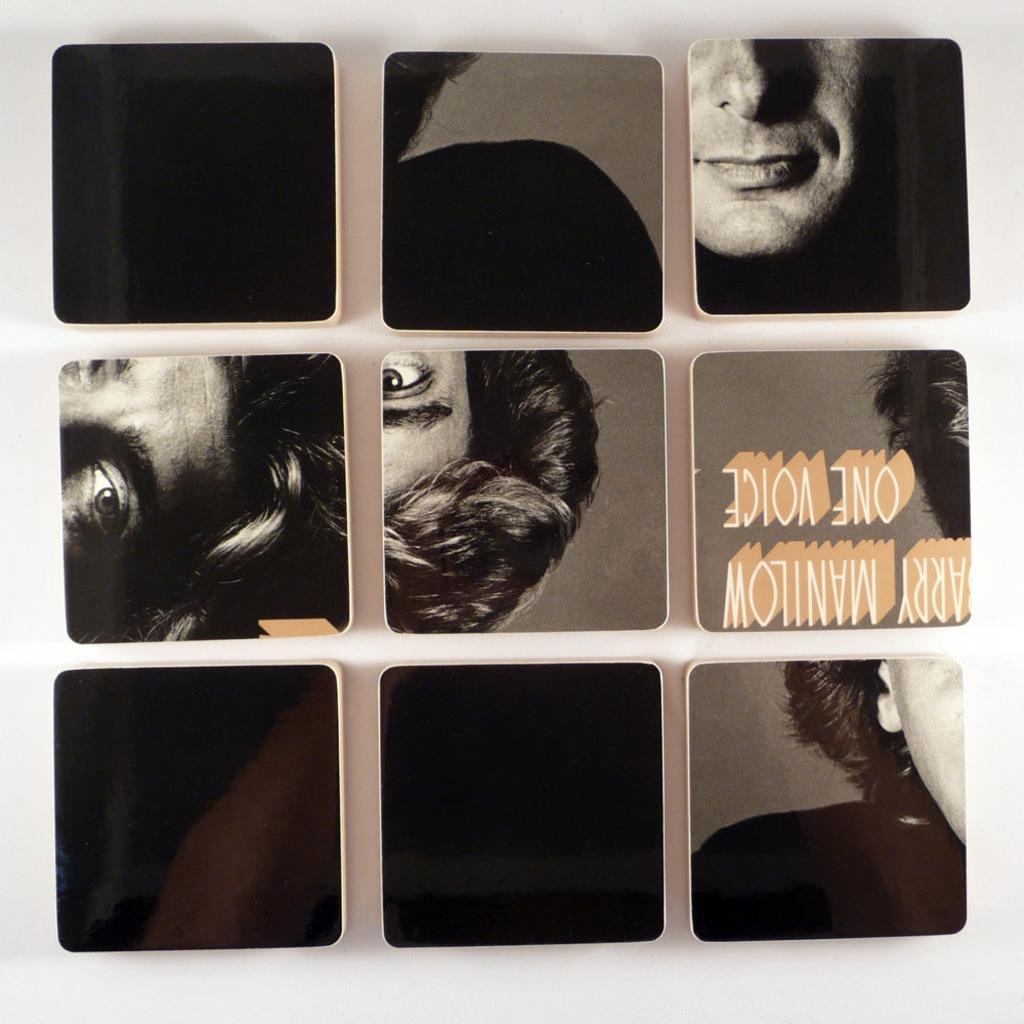Describe this image in one or two sentences. This image looks like an edited photo, in which I can see a person's face and a text. 